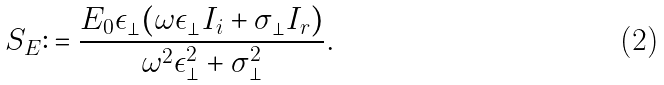<formula> <loc_0><loc_0><loc_500><loc_500>S _ { E } \colon = \frac { E _ { 0 } \epsilon _ { \perp } ( \omega \epsilon _ { \perp } I _ { i } + \sigma _ { \perp } I _ { r } ) } { \omega ^ { 2 } \epsilon _ { \perp } ^ { 2 } + \sigma _ { \perp } ^ { 2 } } .</formula> 